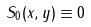Convert formula to latex. <formula><loc_0><loc_0><loc_500><loc_500>S _ { 0 } ( x , y ) \equiv 0</formula> 